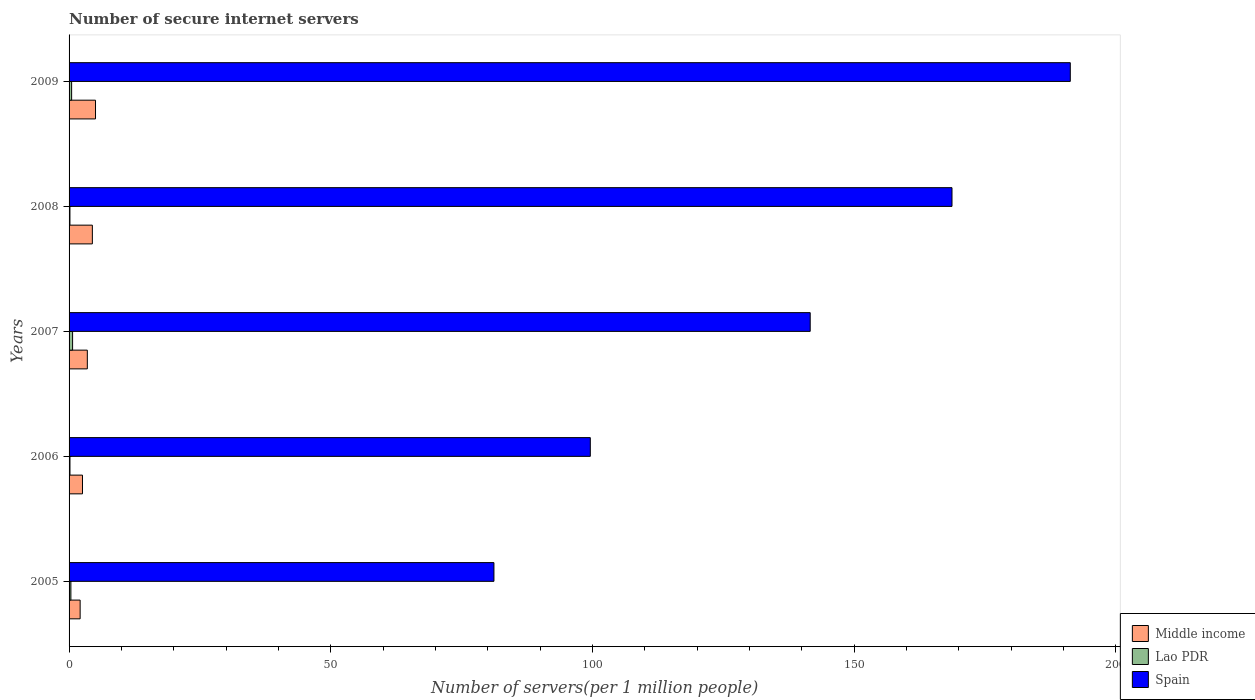How many different coloured bars are there?
Your answer should be compact. 3. How many groups of bars are there?
Offer a terse response. 5. Are the number of bars on each tick of the Y-axis equal?
Make the answer very short. Yes. How many bars are there on the 5th tick from the bottom?
Your answer should be compact. 3. What is the number of secure internet servers in Spain in 2007?
Your answer should be very brief. 141.62. Across all years, what is the maximum number of secure internet servers in Spain?
Make the answer very short. 191.32. Across all years, what is the minimum number of secure internet servers in Middle income?
Offer a terse response. 2.12. In which year was the number of secure internet servers in Lao PDR maximum?
Offer a terse response. 2007. In which year was the number of secure internet servers in Middle income minimum?
Provide a succinct answer. 2005. What is the total number of secure internet servers in Spain in the graph?
Provide a short and direct response. 682.43. What is the difference between the number of secure internet servers in Middle income in 2006 and that in 2008?
Provide a succinct answer. -1.89. What is the difference between the number of secure internet servers in Middle income in 2009 and the number of secure internet servers in Spain in 2007?
Provide a short and direct response. -136.57. What is the average number of secure internet servers in Lao PDR per year?
Your answer should be very brief. 0.37. In the year 2008, what is the difference between the number of secure internet servers in Spain and number of secure internet servers in Lao PDR?
Offer a terse response. 168.55. In how many years, is the number of secure internet servers in Spain greater than 180 ?
Offer a terse response. 1. What is the ratio of the number of secure internet servers in Middle income in 2006 to that in 2009?
Provide a succinct answer. 0.51. Is the difference between the number of secure internet servers in Spain in 2006 and 2009 greater than the difference between the number of secure internet servers in Lao PDR in 2006 and 2009?
Make the answer very short. No. What is the difference between the highest and the second highest number of secure internet servers in Spain?
Your answer should be very brief. 22.6. What is the difference between the highest and the lowest number of secure internet servers in Spain?
Offer a terse response. 110.13. Is the sum of the number of secure internet servers in Lao PDR in 2006 and 2007 greater than the maximum number of secure internet servers in Spain across all years?
Offer a terse response. No. What does the 3rd bar from the top in 2006 represents?
Give a very brief answer. Middle income. What does the 3rd bar from the bottom in 2007 represents?
Keep it short and to the point. Spain. How many years are there in the graph?
Your answer should be compact. 5. What is the difference between two consecutive major ticks on the X-axis?
Keep it short and to the point. 50. Does the graph contain grids?
Provide a succinct answer. No. How are the legend labels stacked?
Your answer should be very brief. Vertical. What is the title of the graph?
Provide a short and direct response. Number of secure internet servers. Does "Bulgaria" appear as one of the legend labels in the graph?
Keep it short and to the point. No. What is the label or title of the X-axis?
Ensure brevity in your answer.  Number of servers(per 1 million people). What is the Number of servers(per 1 million people) in Middle income in 2005?
Keep it short and to the point. 2.12. What is the Number of servers(per 1 million people) in Lao PDR in 2005?
Your answer should be very brief. 0.35. What is the Number of servers(per 1 million people) in Spain in 2005?
Offer a terse response. 81.19. What is the Number of servers(per 1 million people) in Middle income in 2006?
Your answer should be compact. 2.56. What is the Number of servers(per 1 million people) of Lao PDR in 2006?
Provide a short and direct response. 0.17. What is the Number of servers(per 1 million people) of Spain in 2006?
Give a very brief answer. 99.6. What is the Number of servers(per 1 million people) in Middle income in 2007?
Offer a very short reply. 3.49. What is the Number of servers(per 1 million people) of Lao PDR in 2007?
Your answer should be very brief. 0.67. What is the Number of servers(per 1 million people) in Spain in 2007?
Provide a short and direct response. 141.62. What is the Number of servers(per 1 million people) of Middle income in 2008?
Your response must be concise. 4.45. What is the Number of servers(per 1 million people) of Lao PDR in 2008?
Provide a succinct answer. 0.17. What is the Number of servers(per 1 million people) in Spain in 2008?
Provide a succinct answer. 168.71. What is the Number of servers(per 1 million people) of Middle income in 2009?
Keep it short and to the point. 5.05. What is the Number of servers(per 1 million people) in Lao PDR in 2009?
Make the answer very short. 0.49. What is the Number of servers(per 1 million people) of Spain in 2009?
Offer a terse response. 191.32. Across all years, what is the maximum Number of servers(per 1 million people) in Middle income?
Ensure brevity in your answer.  5.05. Across all years, what is the maximum Number of servers(per 1 million people) of Lao PDR?
Provide a short and direct response. 0.67. Across all years, what is the maximum Number of servers(per 1 million people) in Spain?
Your response must be concise. 191.32. Across all years, what is the minimum Number of servers(per 1 million people) of Middle income?
Give a very brief answer. 2.12. Across all years, what is the minimum Number of servers(per 1 million people) in Lao PDR?
Your answer should be very brief. 0.17. Across all years, what is the minimum Number of servers(per 1 million people) in Spain?
Provide a succinct answer. 81.19. What is the total Number of servers(per 1 million people) in Middle income in the graph?
Offer a very short reply. 17.67. What is the total Number of servers(per 1 million people) in Lao PDR in the graph?
Provide a short and direct response. 1.85. What is the total Number of servers(per 1 million people) in Spain in the graph?
Your answer should be compact. 682.43. What is the difference between the Number of servers(per 1 million people) of Middle income in 2005 and that in 2006?
Make the answer very short. -0.45. What is the difference between the Number of servers(per 1 million people) in Lao PDR in 2005 and that in 2006?
Provide a short and direct response. 0.18. What is the difference between the Number of servers(per 1 million people) in Spain in 2005 and that in 2006?
Offer a very short reply. -18.42. What is the difference between the Number of servers(per 1 million people) in Middle income in 2005 and that in 2007?
Keep it short and to the point. -1.37. What is the difference between the Number of servers(per 1 million people) in Lao PDR in 2005 and that in 2007?
Keep it short and to the point. -0.33. What is the difference between the Number of servers(per 1 million people) in Spain in 2005 and that in 2007?
Make the answer very short. -60.43. What is the difference between the Number of servers(per 1 million people) in Middle income in 2005 and that in 2008?
Provide a short and direct response. -2.34. What is the difference between the Number of servers(per 1 million people) of Lao PDR in 2005 and that in 2008?
Your answer should be very brief. 0.18. What is the difference between the Number of servers(per 1 million people) in Spain in 2005 and that in 2008?
Your answer should be very brief. -87.53. What is the difference between the Number of servers(per 1 million people) of Middle income in 2005 and that in 2009?
Provide a succinct answer. -2.94. What is the difference between the Number of servers(per 1 million people) of Lao PDR in 2005 and that in 2009?
Keep it short and to the point. -0.14. What is the difference between the Number of servers(per 1 million people) in Spain in 2005 and that in 2009?
Keep it short and to the point. -110.13. What is the difference between the Number of servers(per 1 million people) in Middle income in 2006 and that in 2007?
Your answer should be compact. -0.92. What is the difference between the Number of servers(per 1 million people) in Lao PDR in 2006 and that in 2007?
Keep it short and to the point. -0.5. What is the difference between the Number of servers(per 1 million people) in Spain in 2006 and that in 2007?
Give a very brief answer. -42.02. What is the difference between the Number of servers(per 1 million people) of Middle income in 2006 and that in 2008?
Your response must be concise. -1.89. What is the difference between the Number of servers(per 1 million people) of Lao PDR in 2006 and that in 2008?
Your answer should be compact. 0.01. What is the difference between the Number of servers(per 1 million people) in Spain in 2006 and that in 2008?
Ensure brevity in your answer.  -69.11. What is the difference between the Number of servers(per 1 million people) of Middle income in 2006 and that in 2009?
Your answer should be compact. -2.49. What is the difference between the Number of servers(per 1 million people) in Lao PDR in 2006 and that in 2009?
Ensure brevity in your answer.  -0.32. What is the difference between the Number of servers(per 1 million people) in Spain in 2006 and that in 2009?
Your answer should be very brief. -91.72. What is the difference between the Number of servers(per 1 million people) in Middle income in 2007 and that in 2008?
Ensure brevity in your answer.  -0.96. What is the difference between the Number of servers(per 1 million people) in Lao PDR in 2007 and that in 2008?
Offer a very short reply. 0.51. What is the difference between the Number of servers(per 1 million people) of Spain in 2007 and that in 2008?
Your response must be concise. -27.09. What is the difference between the Number of servers(per 1 million people) of Middle income in 2007 and that in 2009?
Make the answer very short. -1.56. What is the difference between the Number of servers(per 1 million people) of Lao PDR in 2007 and that in 2009?
Your answer should be compact. 0.19. What is the difference between the Number of servers(per 1 million people) of Spain in 2007 and that in 2009?
Give a very brief answer. -49.7. What is the difference between the Number of servers(per 1 million people) in Middle income in 2008 and that in 2009?
Your answer should be compact. -0.6. What is the difference between the Number of servers(per 1 million people) in Lao PDR in 2008 and that in 2009?
Make the answer very short. -0.32. What is the difference between the Number of servers(per 1 million people) in Spain in 2008 and that in 2009?
Your response must be concise. -22.6. What is the difference between the Number of servers(per 1 million people) of Middle income in 2005 and the Number of servers(per 1 million people) of Lao PDR in 2006?
Offer a very short reply. 1.94. What is the difference between the Number of servers(per 1 million people) of Middle income in 2005 and the Number of servers(per 1 million people) of Spain in 2006?
Give a very brief answer. -97.48. What is the difference between the Number of servers(per 1 million people) in Lao PDR in 2005 and the Number of servers(per 1 million people) in Spain in 2006?
Offer a very short reply. -99.25. What is the difference between the Number of servers(per 1 million people) in Middle income in 2005 and the Number of servers(per 1 million people) in Lao PDR in 2007?
Ensure brevity in your answer.  1.44. What is the difference between the Number of servers(per 1 million people) in Middle income in 2005 and the Number of servers(per 1 million people) in Spain in 2007?
Offer a terse response. -139.5. What is the difference between the Number of servers(per 1 million people) in Lao PDR in 2005 and the Number of servers(per 1 million people) in Spain in 2007?
Provide a short and direct response. -141.27. What is the difference between the Number of servers(per 1 million people) of Middle income in 2005 and the Number of servers(per 1 million people) of Lao PDR in 2008?
Your answer should be very brief. 1.95. What is the difference between the Number of servers(per 1 million people) in Middle income in 2005 and the Number of servers(per 1 million people) in Spain in 2008?
Make the answer very short. -166.6. What is the difference between the Number of servers(per 1 million people) in Lao PDR in 2005 and the Number of servers(per 1 million people) in Spain in 2008?
Ensure brevity in your answer.  -168.36. What is the difference between the Number of servers(per 1 million people) of Middle income in 2005 and the Number of servers(per 1 million people) of Lao PDR in 2009?
Offer a terse response. 1.63. What is the difference between the Number of servers(per 1 million people) in Middle income in 2005 and the Number of servers(per 1 million people) in Spain in 2009?
Provide a short and direct response. -189.2. What is the difference between the Number of servers(per 1 million people) in Lao PDR in 2005 and the Number of servers(per 1 million people) in Spain in 2009?
Your answer should be very brief. -190.97. What is the difference between the Number of servers(per 1 million people) of Middle income in 2006 and the Number of servers(per 1 million people) of Lao PDR in 2007?
Keep it short and to the point. 1.89. What is the difference between the Number of servers(per 1 million people) in Middle income in 2006 and the Number of servers(per 1 million people) in Spain in 2007?
Offer a terse response. -139.06. What is the difference between the Number of servers(per 1 million people) of Lao PDR in 2006 and the Number of servers(per 1 million people) of Spain in 2007?
Your response must be concise. -141.45. What is the difference between the Number of servers(per 1 million people) of Middle income in 2006 and the Number of servers(per 1 million people) of Lao PDR in 2008?
Keep it short and to the point. 2.4. What is the difference between the Number of servers(per 1 million people) in Middle income in 2006 and the Number of servers(per 1 million people) in Spain in 2008?
Give a very brief answer. -166.15. What is the difference between the Number of servers(per 1 million people) in Lao PDR in 2006 and the Number of servers(per 1 million people) in Spain in 2008?
Offer a terse response. -168.54. What is the difference between the Number of servers(per 1 million people) of Middle income in 2006 and the Number of servers(per 1 million people) of Lao PDR in 2009?
Keep it short and to the point. 2.08. What is the difference between the Number of servers(per 1 million people) of Middle income in 2006 and the Number of servers(per 1 million people) of Spain in 2009?
Provide a succinct answer. -188.75. What is the difference between the Number of servers(per 1 million people) of Lao PDR in 2006 and the Number of servers(per 1 million people) of Spain in 2009?
Ensure brevity in your answer.  -191.15. What is the difference between the Number of servers(per 1 million people) of Middle income in 2007 and the Number of servers(per 1 million people) of Lao PDR in 2008?
Provide a succinct answer. 3.32. What is the difference between the Number of servers(per 1 million people) in Middle income in 2007 and the Number of servers(per 1 million people) in Spain in 2008?
Your response must be concise. -165.22. What is the difference between the Number of servers(per 1 million people) in Lao PDR in 2007 and the Number of servers(per 1 million people) in Spain in 2008?
Offer a terse response. -168.04. What is the difference between the Number of servers(per 1 million people) in Middle income in 2007 and the Number of servers(per 1 million people) in Lao PDR in 2009?
Keep it short and to the point. 3. What is the difference between the Number of servers(per 1 million people) of Middle income in 2007 and the Number of servers(per 1 million people) of Spain in 2009?
Ensure brevity in your answer.  -187.83. What is the difference between the Number of servers(per 1 million people) in Lao PDR in 2007 and the Number of servers(per 1 million people) in Spain in 2009?
Ensure brevity in your answer.  -190.64. What is the difference between the Number of servers(per 1 million people) in Middle income in 2008 and the Number of servers(per 1 million people) in Lao PDR in 2009?
Offer a terse response. 3.96. What is the difference between the Number of servers(per 1 million people) of Middle income in 2008 and the Number of servers(per 1 million people) of Spain in 2009?
Provide a short and direct response. -186.87. What is the difference between the Number of servers(per 1 million people) in Lao PDR in 2008 and the Number of servers(per 1 million people) in Spain in 2009?
Ensure brevity in your answer.  -191.15. What is the average Number of servers(per 1 million people) of Middle income per year?
Offer a very short reply. 3.53. What is the average Number of servers(per 1 million people) in Lao PDR per year?
Keep it short and to the point. 0.37. What is the average Number of servers(per 1 million people) in Spain per year?
Keep it short and to the point. 136.49. In the year 2005, what is the difference between the Number of servers(per 1 million people) in Middle income and Number of servers(per 1 million people) in Lao PDR?
Your answer should be very brief. 1.77. In the year 2005, what is the difference between the Number of servers(per 1 million people) in Middle income and Number of servers(per 1 million people) in Spain?
Offer a very short reply. -79.07. In the year 2005, what is the difference between the Number of servers(per 1 million people) in Lao PDR and Number of servers(per 1 million people) in Spain?
Provide a short and direct response. -80.84. In the year 2006, what is the difference between the Number of servers(per 1 million people) in Middle income and Number of servers(per 1 million people) in Lao PDR?
Your response must be concise. 2.39. In the year 2006, what is the difference between the Number of servers(per 1 million people) in Middle income and Number of servers(per 1 million people) in Spain?
Provide a short and direct response. -97.04. In the year 2006, what is the difference between the Number of servers(per 1 million people) in Lao PDR and Number of servers(per 1 million people) in Spain?
Your response must be concise. -99.43. In the year 2007, what is the difference between the Number of servers(per 1 million people) in Middle income and Number of servers(per 1 million people) in Lao PDR?
Provide a succinct answer. 2.81. In the year 2007, what is the difference between the Number of servers(per 1 million people) in Middle income and Number of servers(per 1 million people) in Spain?
Provide a succinct answer. -138.13. In the year 2007, what is the difference between the Number of servers(per 1 million people) of Lao PDR and Number of servers(per 1 million people) of Spain?
Make the answer very short. -140.95. In the year 2008, what is the difference between the Number of servers(per 1 million people) in Middle income and Number of servers(per 1 million people) in Lao PDR?
Offer a very short reply. 4.29. In the year 2008, what is the difference between the Number of servers(per 1 million people) of Middle income and Number of servers(per 1 million people) of Spain?
Provide a succinct answer. -164.26. In the year 2008, what is the difference between the Number of servers(per 1 million people) in Lao PDR and Number of servers(per 1 million people) in Spain?
Your response must be concise. -168.55. In the year 2009, what is the difference between the Number of servers(per 1 million people) in Middle income and Number of servers(per 1 million people) in Lao PDR?
Your response must be concise. 4.56. In the year 2009, what is the difference between the Number of servers(per 1 million people) in Middle income and Number of servers(per 1 million people) in Spain?
Provide a succinct answer. -186.26. In the year 2009, what is the difference between the Number of servers(per 1 million people) of Lao PDR and Number of servers(per 1 million people) of Spain?
Give a very brief answer. -190.83. What is the ratio of the Number of servers(per 1 million people) of Middle income in 2005 to that in 2006?
Offer a very short reply. 0.83. What is the ratio of the Number of servers(per 1 million people) in Lao PDR in 2005 to that in 2006?
Provide a succinct answer. 2.03. What is the ratio of the Number of servers(per 1 million people) in Spain in 2005 to that in 2006?
Give a very brief answer. 0.82. What is the ratio of the Number of servers(per 1 million people) in Middle income in 2005 to that in 2007?
Provide a succinct answer. 0.61. What is the ratio of the Number of servers(per 1 million people) in Lao PDR in 2005 to that in 2007?
Give a very brief answer. 0.52. What is the ratio of the Number of servers(per 1 million people) of Spain in 2005 to that in 2007?
Ensure brevity in your answer.  0.57. What is the ratio of the Number of servers(per 1 million people) in Middle income in 2005 to that in 2008?
Provide a short and direct response. 0.48. What is the ratio of the Number of servers(per 1 million people) in Lao PDR in 2005 to that in 2008?
Your response must be concise. 2.1. What is the ratio of the Number of servers(per 1 million people) of Spain in 2005 to that in 2008?
Keep it short and to the point. 0.48. What is the ratio of the Number of servers(per 1 million people) of Middle income in 2005 to that in 2009?
Provide a short and direct response. 0.42. What is the ratio of the Number of servers(per 1 million people) of Lao PDR in 2005 to that in 2009?
Your answer should be very brief. 0.71. What is the ratio of the Number of servers(per 1 million people) in Spain in 2005 to that in 2009?
Keep it short and to the point. 0.42. What is the ratio of the Number of servers(per 1 million people) of Middle income in 2006 to that in 2007?
Make the answer very short. 0.74. What is the ratio of the Number of servers(per 1 million people) in Lao PDR in 2006 to that in 2007?
Offer a terse response. 0.25. What is the ratio of the Number of servers(per 1 million people) of Spain in 2006 to that in 2007?
Your response must be concise. 0.7. What is the ratio of the Number of servers(per 1 million people) in Middle income in 2006 to that in 2008?
Your answer should be compact. 0.58. What is the ratio of the Number of servers(per 1 million people) of Lao PDR in 2006 to that in 2008?
Provide a short and direct response. 1.04. What is the ratio of the Number of servers(per 1 million people) in Spain in 2006 to that in 2008?
Give a very brief answer. 0.59. What is the ratio of the Number of servers(per 1 million people) of Middle income in 2006 to that in 2009?
Provide a succinct answer. 0.51. What is the ratio of the Number of servers(per 1 million people) in Lao PDR in 2006 to that in 2009?
Your answer should be compact. 0.35. What is the ratio of the Number of servers(per 1 million people) of Spain in 2006 to that in 2009?
Provide a succinct answer. 0.52. What is the ratio of the Number of servers(per 1 million people) in Middle income in 2007 to that in 2008?
Offer a very short reply. 0.78. What is the ratio of the Number of servers(per 1 million people) in Lao PDR in 2007 to that in 2008?
Your answer should be compact. 4.07. What is the ratio of the Number of servers(per 1 million people) in Spain in 2007 to that in 2008?
Your answer should be very brief. 0.84. What is the ratio of the Number of servers(per 1 million people) of Middle income in 2007 to that in 2009?
Your answer should be compact. 0.69. What is the ratio of the Number of servers(per 1 million people) of Lao PDR in 2007 to that in 2009?
Your answer should be compact. 1.38. What is the ratio of the Number of servers(per 1 million people) in Spain in 2007 to that in 2009?
Make the answer very short. 0.74. What is the ratio of the Number of servers(per 1 million people) of Middle income in 2008 to that in 2009?
Provide a short and direct response. 0.88. What is the ratio of the Number of servers(per 1 million people) in Lao PDR in 2008 to that in 2009?
Make the answer very short. 0.34. What is the ratio of the Number of servers(per 1 million people) in Spain in 2008 to that in 2009?
Give a very brief answer. 0.88. What is the difference between the highest and the second highest Number of servers(per 1 million people) in Middle income?
Make the answer very short. 0.6. What is the difference between the highest and the second highest Number of servers(per 1 million people) in Lao PDR?
Ensure brevity in your answer.  0.19. What is the difference between the highest and the second highest Number of servers(per 1 million people) in Spain?
Your answer should be compact. 22.6. What is the difference between the highest and the lowest Number of servers(per 1 million people) in Middle income?
Offer a terse response. 2.94. What is the difference between the highest and the lowest Number of servers(per 1 million people) in Lao PDR?
Make the answer very short. 0.51. What is the difference between the highest and the lowest Number of servers(per 1 million people) of Spain?
Keep it short and to the point. 110.13. 